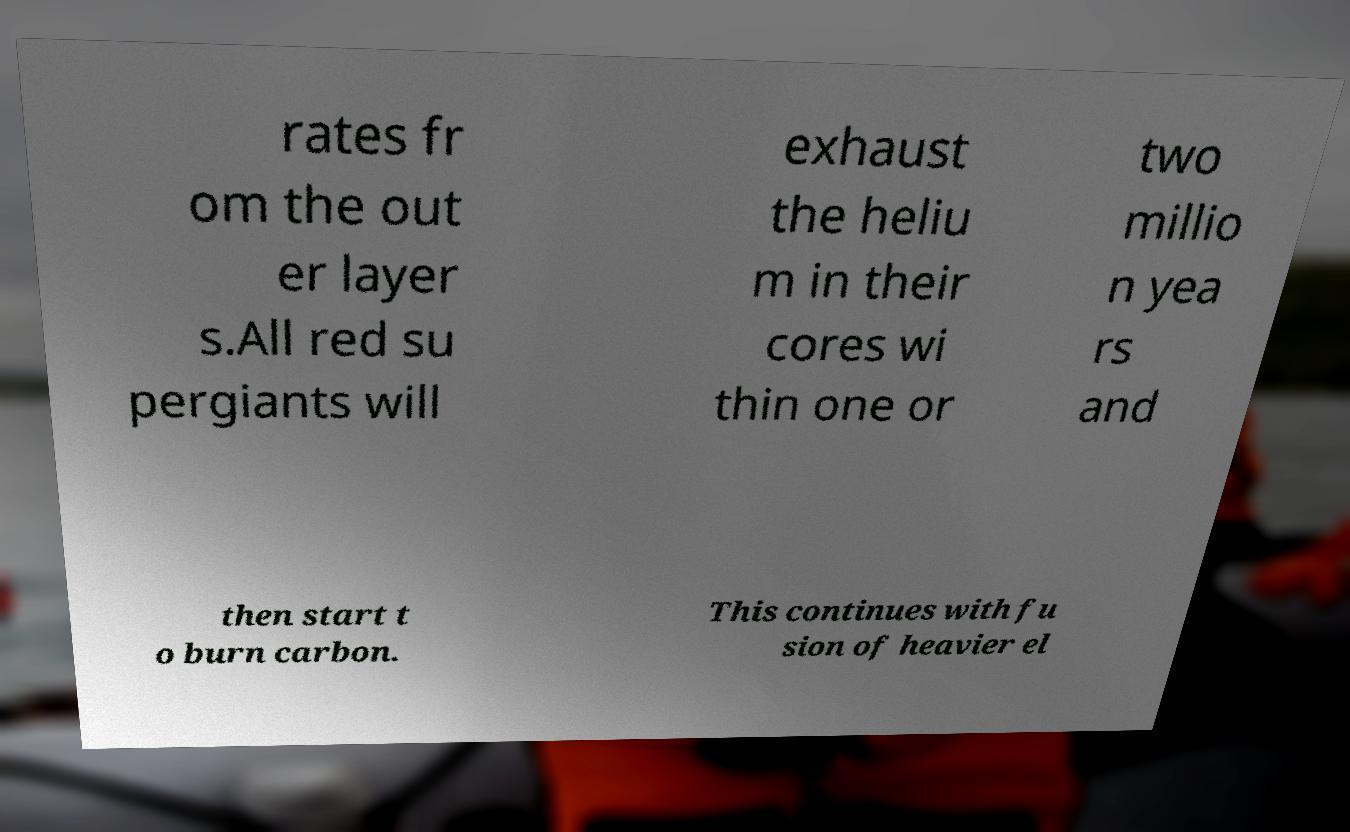Please read and relay the text visible in this image. What does it say? rates fr om the out er layer s.All red su pergiants will exhaust the heliu m in their cores wi thin one or two millio n yea rs and then start t o burn carbon. This continues with fu sion of heavier el 